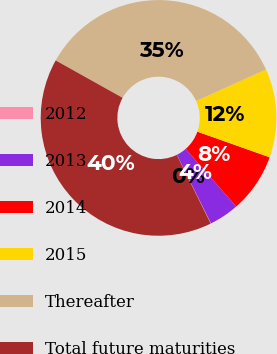<chart> <loc_0><loc_0><loc_500><loc_500><pie_chart><fcel>2012<fcel>2013<fcel>2014<fcel>2015<fcel>Thereafter<fcel>Total future maturities<nl><fcel>0.06%<fcel>4.1%<fcel>8.13%<fcel>12.16%<fcel>35.15%<fcel>40.39%<nl></chart> 